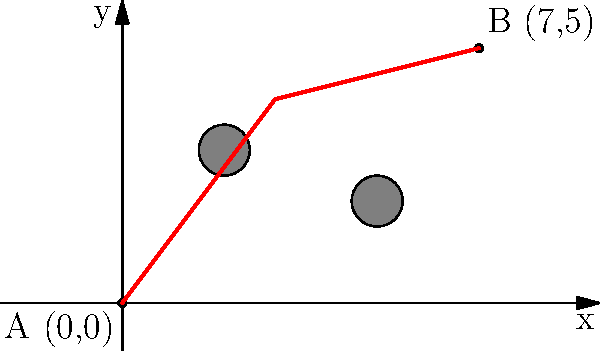In the journey of self-discovery, we often encounter obstacles that require us to deviate from the direct path. Consider the coordinate plane above, where point A(0,0) represents the beginning of one's journey, and point B(7,5) represents the destination of inner peace. The gray circles are obstacles that must be avoided. What is the length of the shortest path from A to B while avoiding the obstacles? Round your answer to two decimal places. To find the shortest path while avoiding obstacles, we'll follow these steps:

1. Observe that the direct path from A to B is blocked by the obstacles.

2. The shortest path that avoids the obstacles appears to be:
   A(0,0) → (3,4) → B(7,5)

3. Calculate the length of this path:
   a) Length of segment from (0,0) to (3,4):
      $\sqrt{(3-0)^2 + (4-0)^2} = \sqrt{9 + 16} = \sqrt{25} = 5$

   b) Length of segment from (3,4) to (7,5):
      $\sqrt{(7-3)^2 + (5-4)^2} = \sqrt{16 + 1} = \sqrt{17}$

4. Total length of the path:
   $5 + \sqrt{17} \approx 9.1231$

5. Rounding to two decimal places:
   $9.12$

This path represents the journey of self-discovery, where one must navigate around life's challenges (obstacles) to reach inner peace (the destination).
Answer: $9.12$ 